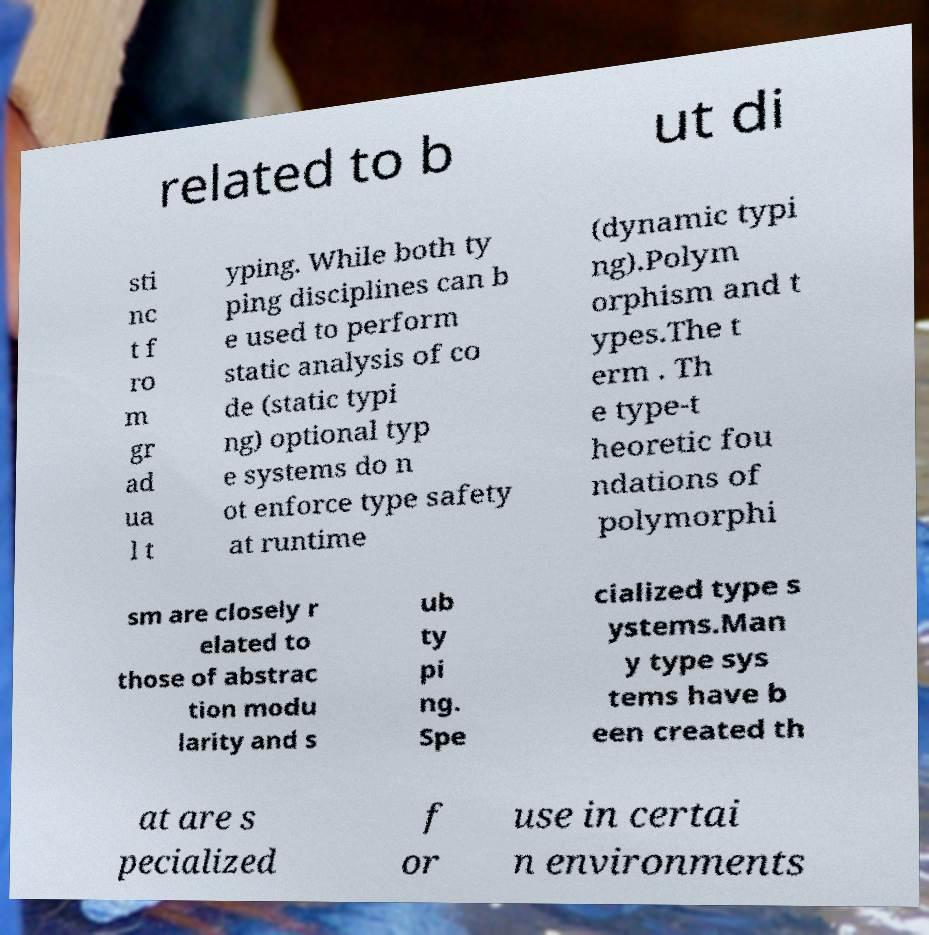For documentation purposes, I need the text within this image transcribed. Could you provide that? related to b ut di sti nc t f ro m gr ad ua l t yping. While both ty ping disciplines can b e used to perform static analysis of co de (static typi ng) optional typ e systems do n ot enforce type safety at runtime (dynamic typi ng).Polym orphism and t ypes.The t erm . Th e type-t heoretic fou ndations of polymorphi sm are closely r elated to those of abstrac tion modu larity and s ub ty pi ng. Spe cialized type s ystems.Man y type sys tems have b een created th at are s pecialized f or use in certai n environments 